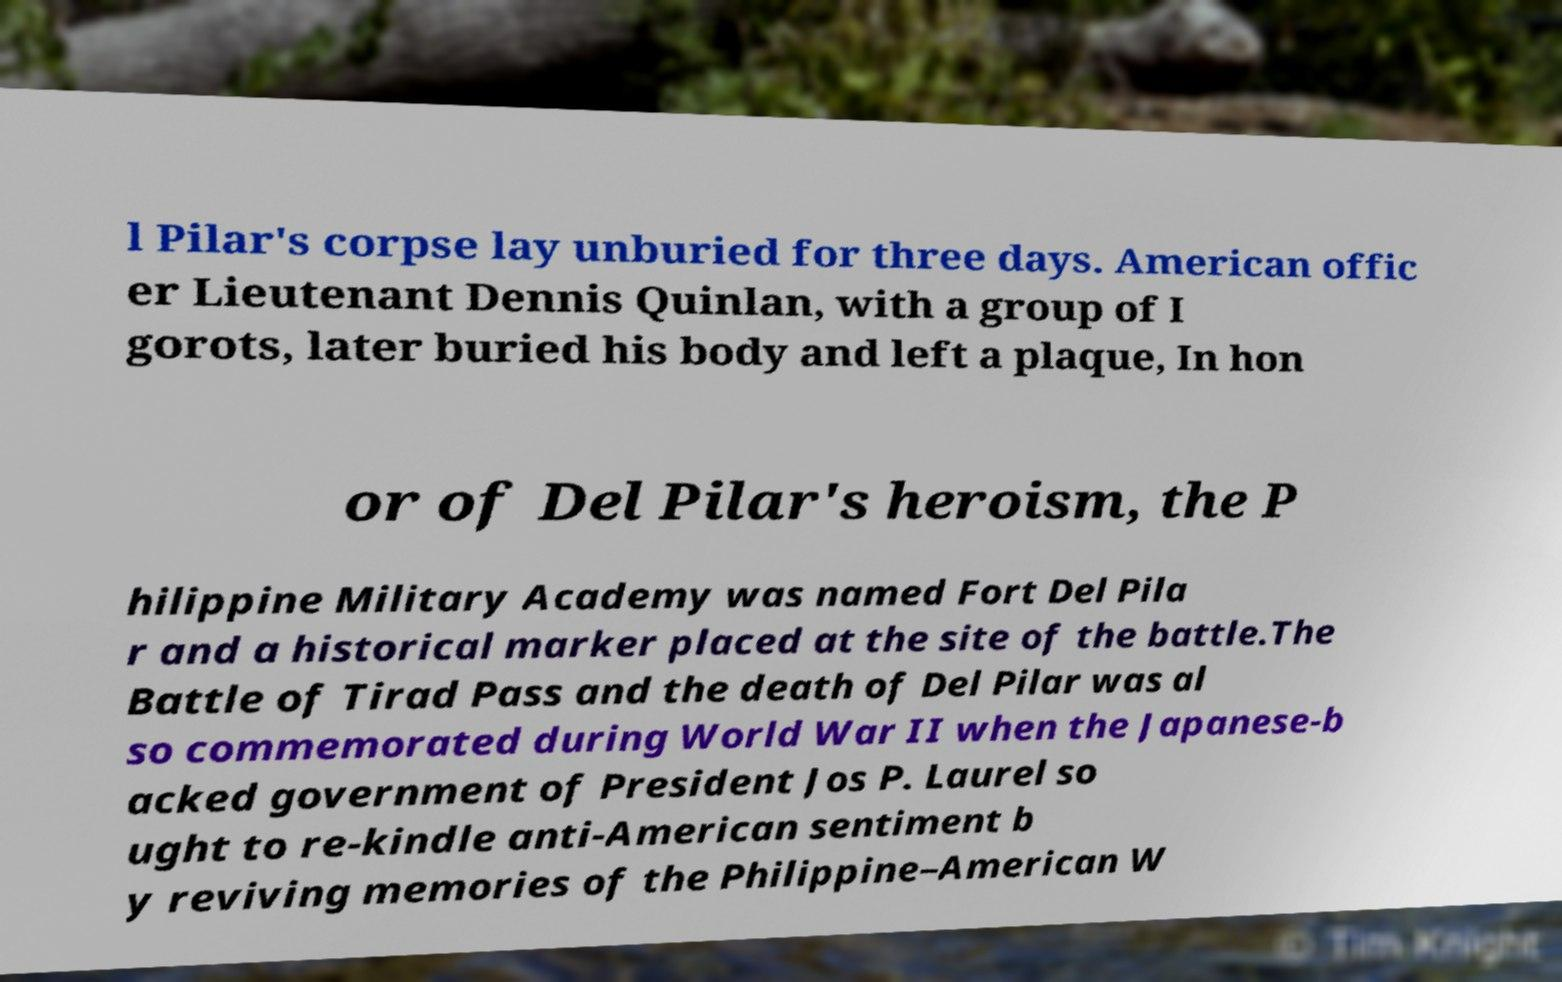Please read and relay the text visible in this image. What does it say? l Pilar's corpse lay unburied for three days. American offic er Lieutenant Dennis Quinlan, with a group of I gorots, later buried his body and left a plaque, In hon or of Del Pilar's heroism, the P hilippine Military Academy was named Fort Del Pila r and a historical marker placed at the site of the battle.The Battle of Tirad Pass and the death of Del Pilar was al so commemorated during World War II when the Japanese-b acked government of President Jos P. Laurel so ught to re-kindle anti-American sentiment b y reviving memories of the Philippine–American W 